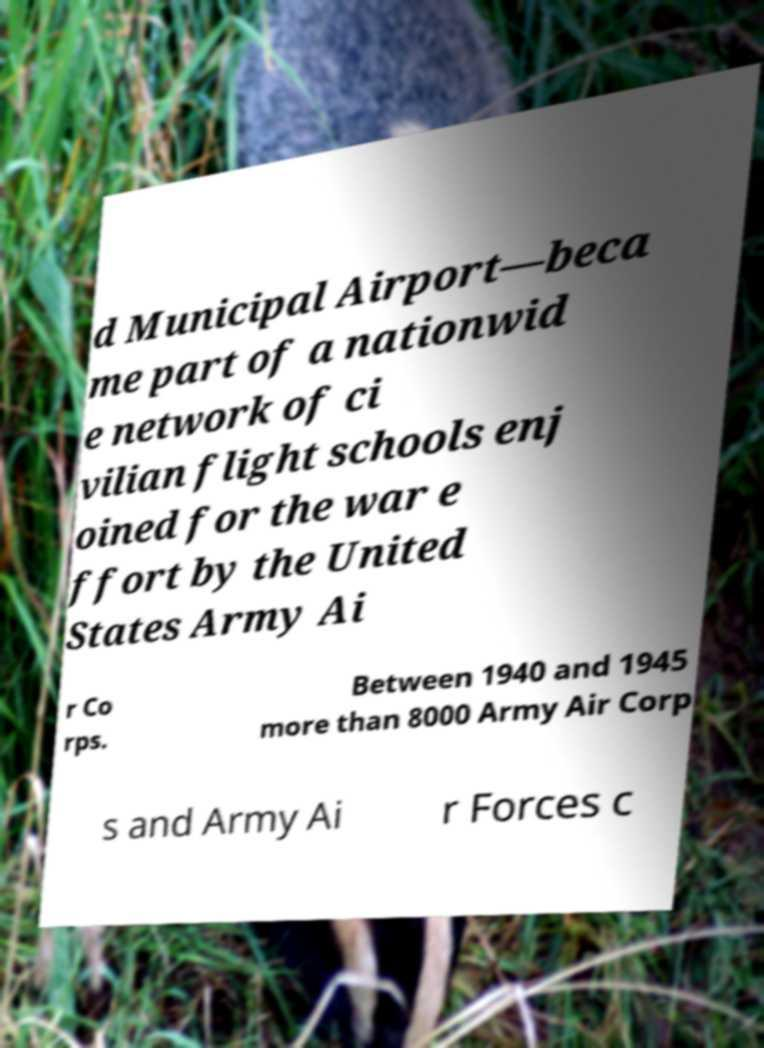There's text embedded in this image that I need extracted. Can you transcribe it verbatim? d Municipal Airport—beca me part of a nationwid e network of ci vilian flight schools enj oined for the war e ffort by the United States Army Ai r Co rps. Between 1940 and 1945 more than 8000 Army Air Corp s and Army Ai r Forces c 